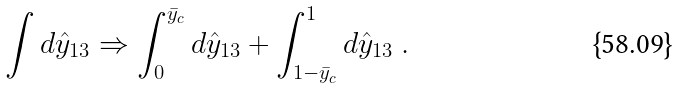<formula> <loc_0><loc_0><loc_500><loc_500>\int d \hat { y } _ { 1 3 } \Rightarrow \int _ { 0 } ^ { \bar { y } _ { c } } d \hat { y } _ { 1 3 } + \int _ { 1 - \bar { y } _ { c } } ^ { 1 } d \hat { y } _ { 1 3 } \ .</formula> 